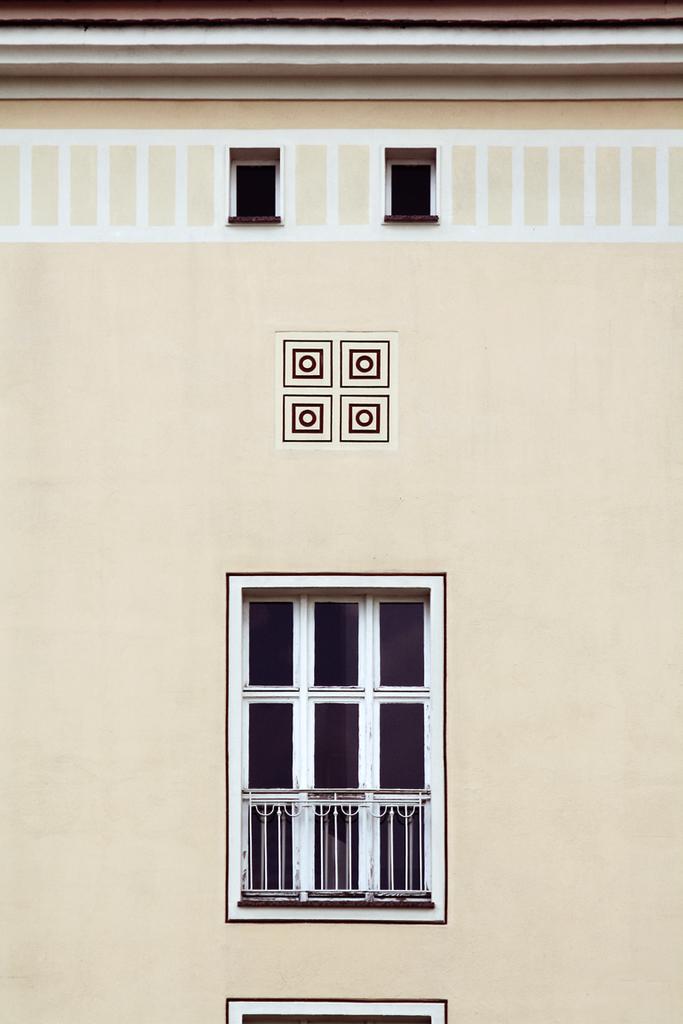In one or two sentences, can you explain what this image depicts? In this image I can see the wall with the windows. 